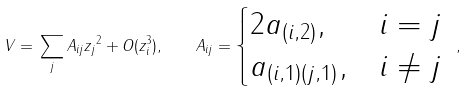Convert formula to latex. <formula><loc_0><loc_0><loc_500><loc_500>V = \| \sum _ { j } A _ { i j } z _ { j } \| ^ { 2 } + O ( z _ { i } ^ { 3 } ) , \quad A _ { i j } = \begin{cases} 2 a _ { ( i , 2 ) } , & i = j \\ a _ { ( i , 1 ) ( j , 1 ) } , & i \ne j \end{cases} \ ,</formula> 